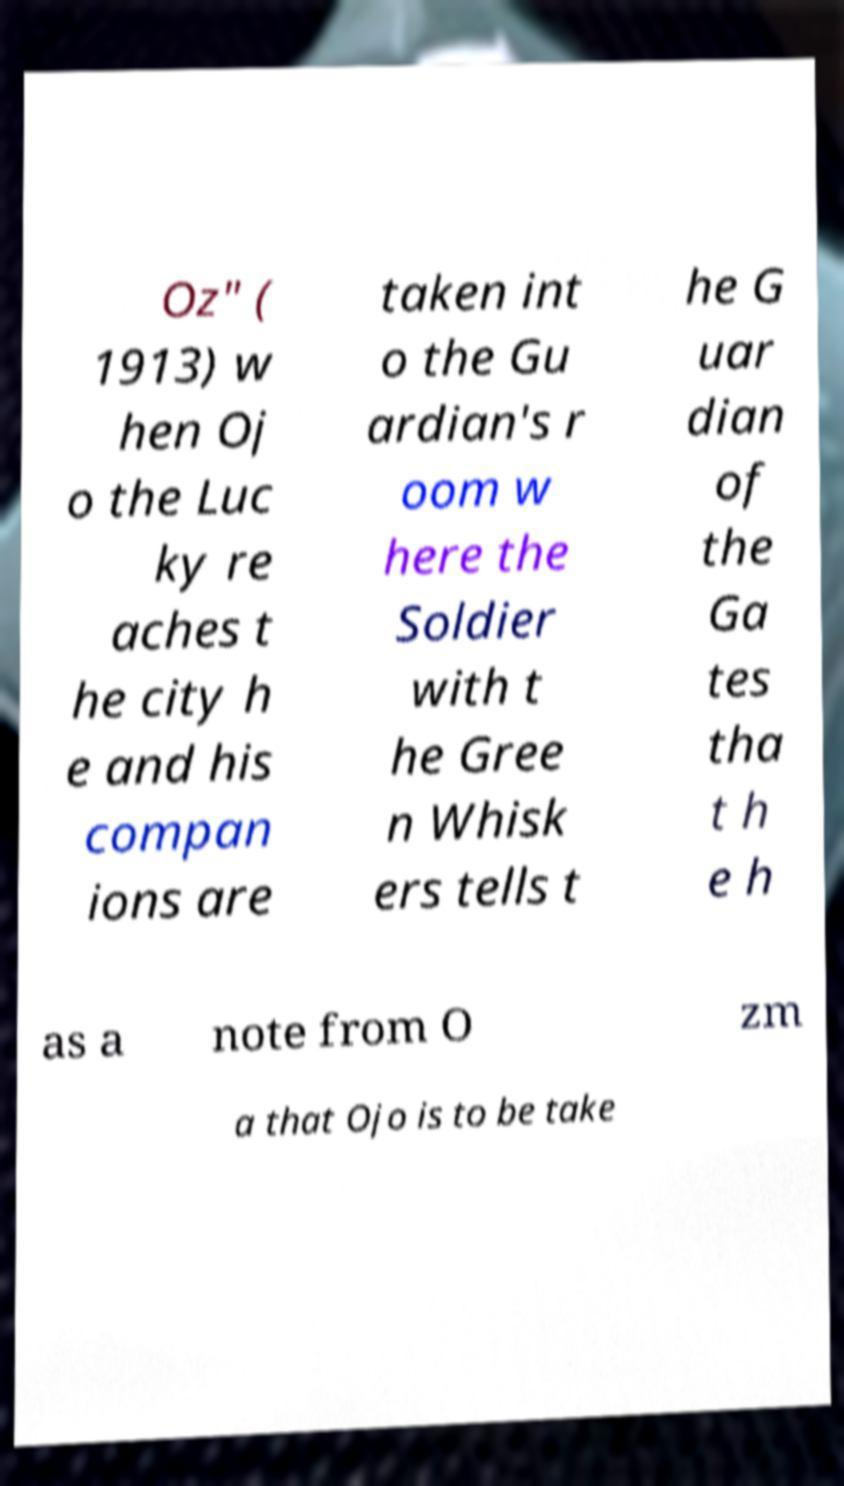Could you extract and type out the text from this image? Oz" ( 1913) w hen Oj o the Luc ky re aches t he city h e and his compan ions are taken int o the Gu ardian's r oom w here the Soldier with t he Gree n Whisk ers tells t he G uar dian of the Ga tes tha t h e h as a note from O zm a that Ojo is to be take 